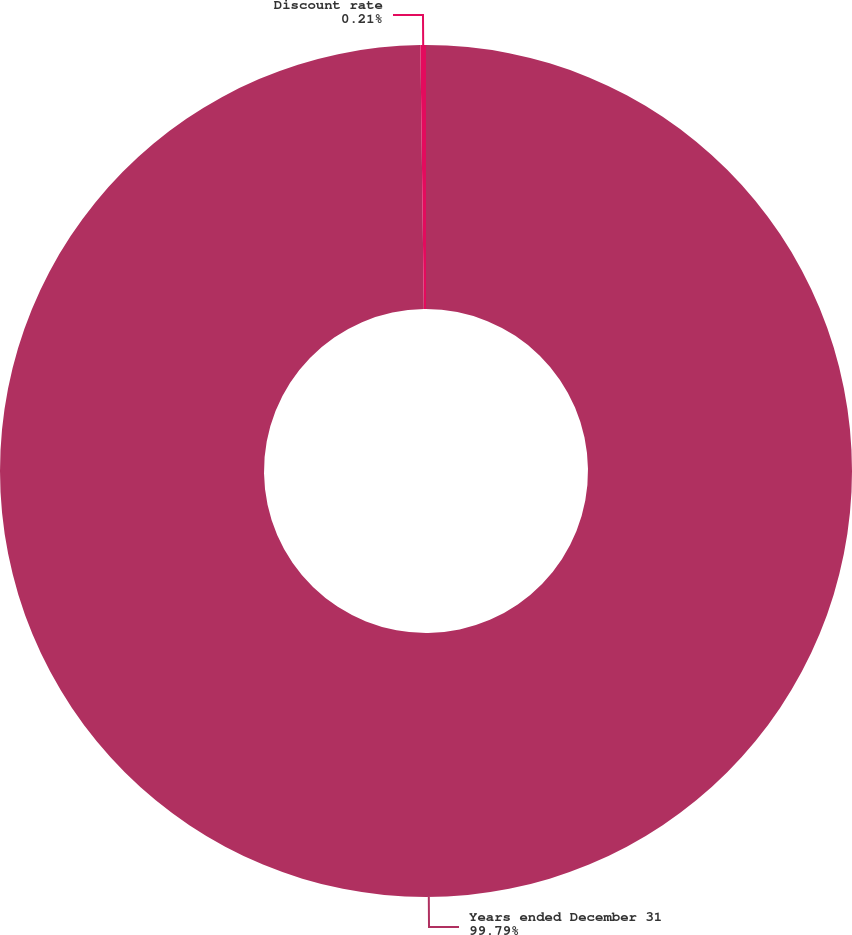Convert chart to OTSL. <chart><loc_0><loc_0><loc_500><loc_500><pie_chart><fcel>Years ended December 31<fcel>Discount rate<nl><fcel>99.79%<fcel>0.21%<nl></chart> 